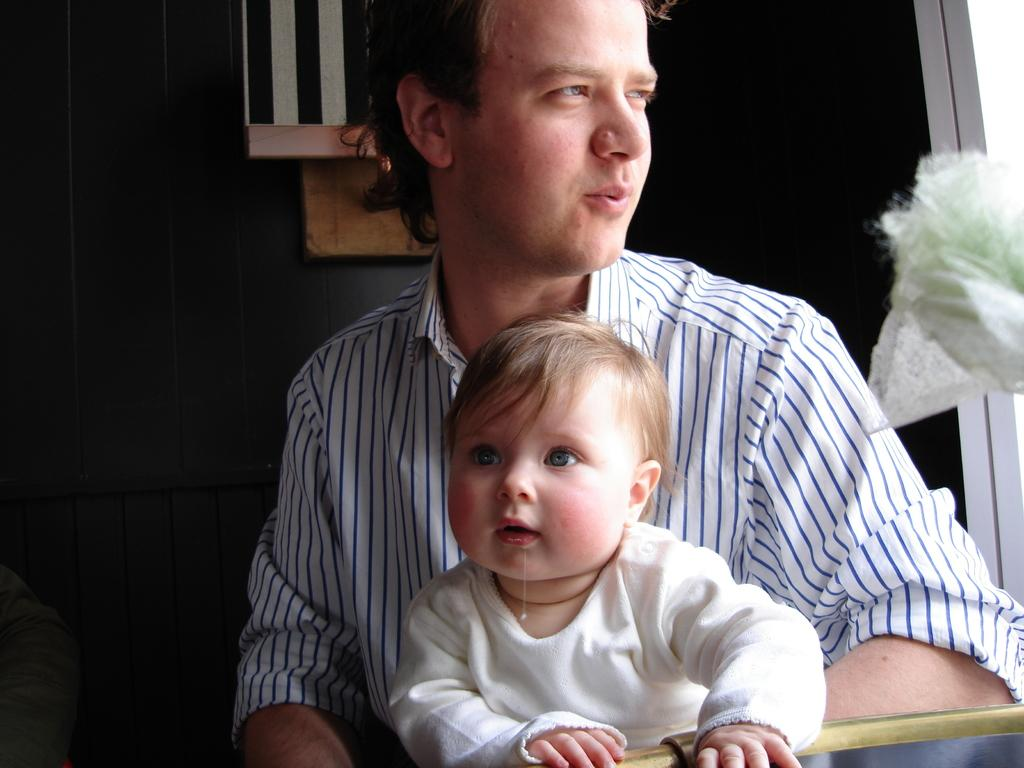Who is the main subject in the image? There is a man in the image. What is the man wearing? The man is wearing a white shirt. Where is the man sitting in the image? The man is sitting in the front. What is the man doing with the small boy? The man is holding a small boy. What can be observed about the background of the image? The background of the image is dark. What type of behavior can be seen in the snakes in the image? There are no snakes present in the image, so their behavior cannot be observed. What type of apparel is the man wearing on his feet? The provided facts do not mention the man's footwear, so it cannot be determined from the image. 